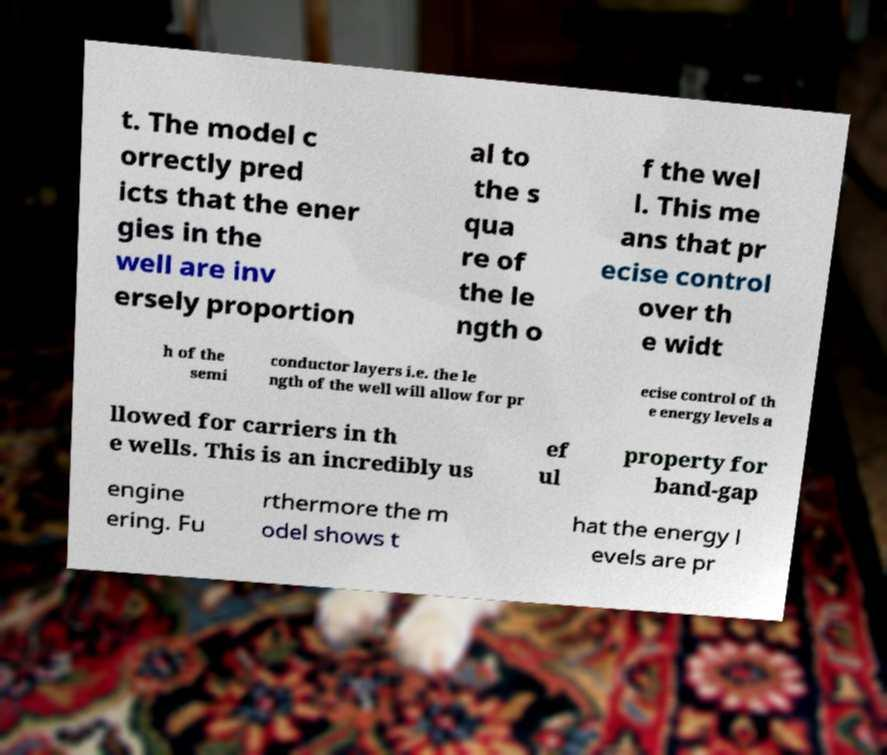Could you extract and type out the text from this image? t. The model c orrectly pred icts that the ener gies in the well are inv ersely proportion al to the s qua re of the le ngth o f the wel l. This me ans that pr ecise control over th e widt h of the semi conductor layers i.e. the le ngth of the well will allow for pr ecise control of th e energy levels a llowed for carriers in th e wells. This is an incredibly us ef ul property for band-gap engine ering. Fu rthermore the m odel shows t hat the energy l evels are pr 